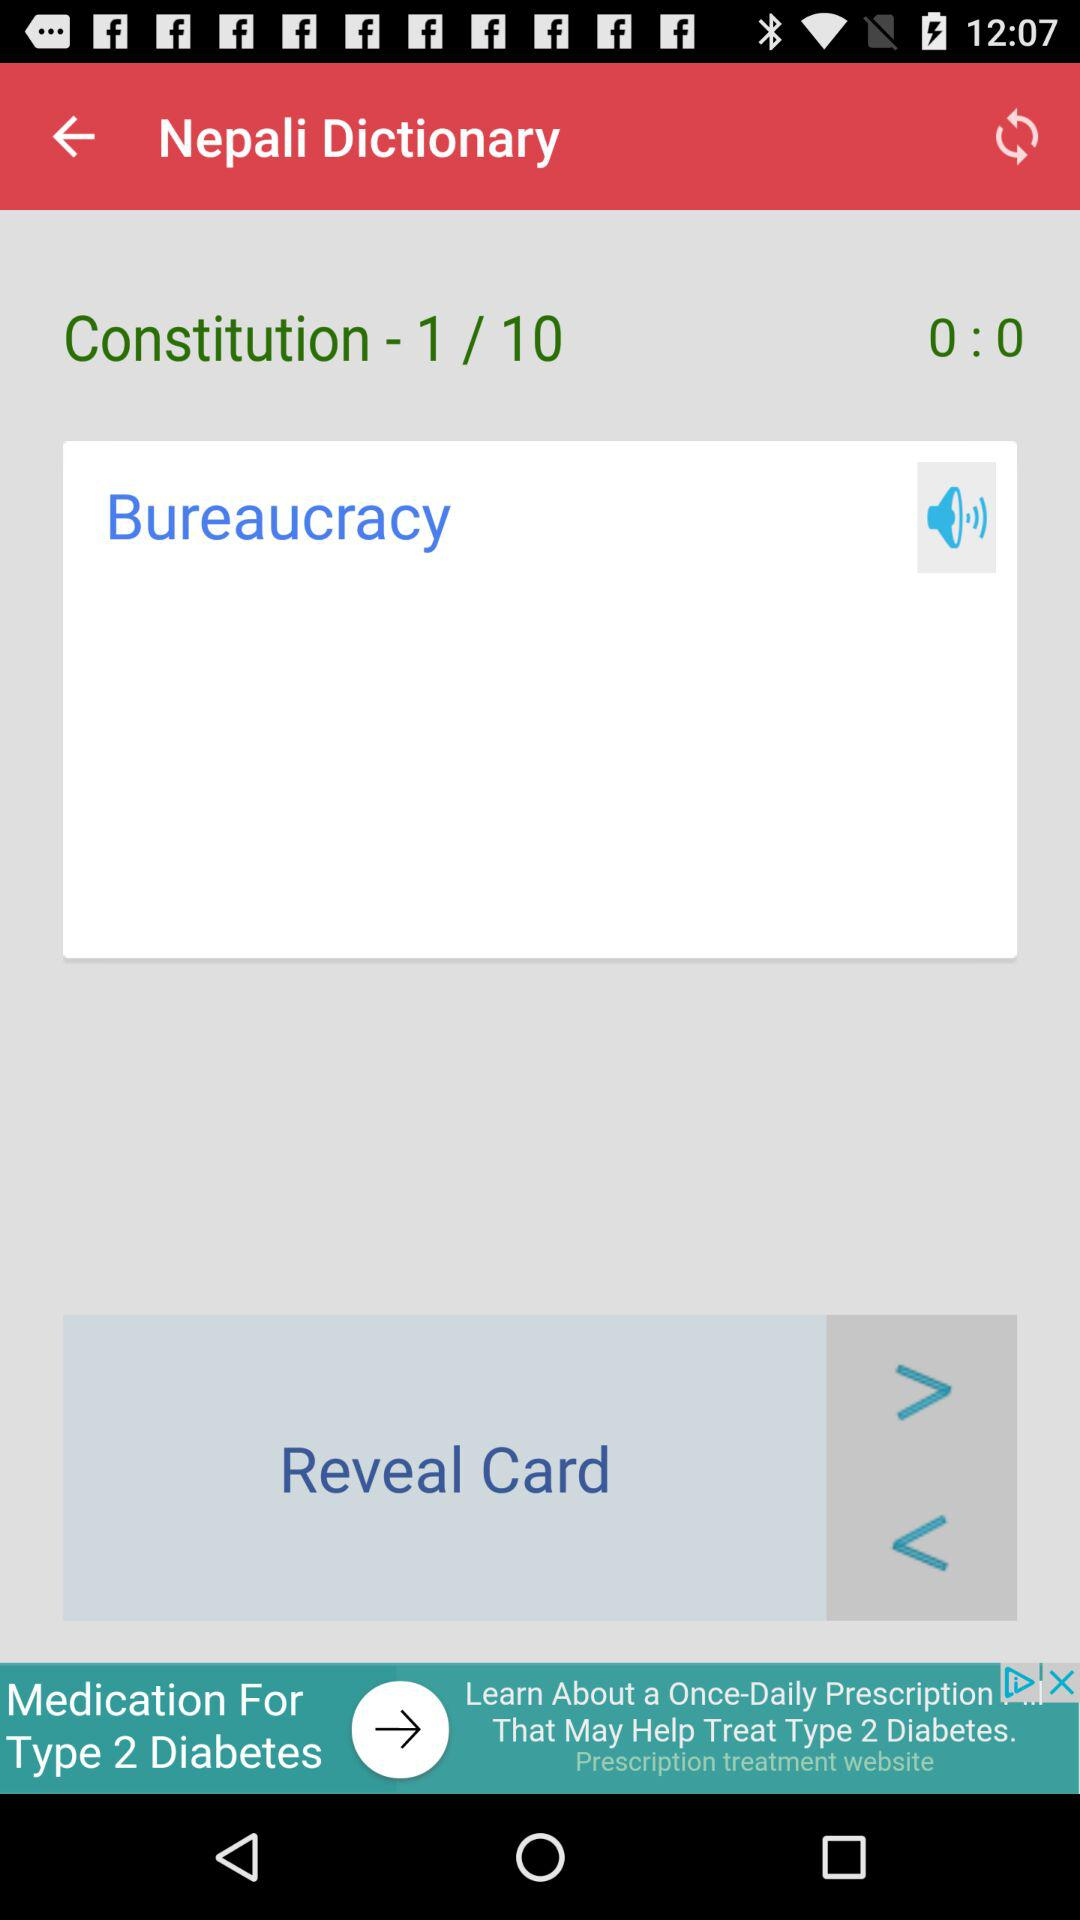What is the total number of constitutions present in the "Nepali Dictionary"? The total number of constitutions present in the "Nepali Dictionary" is 10. 